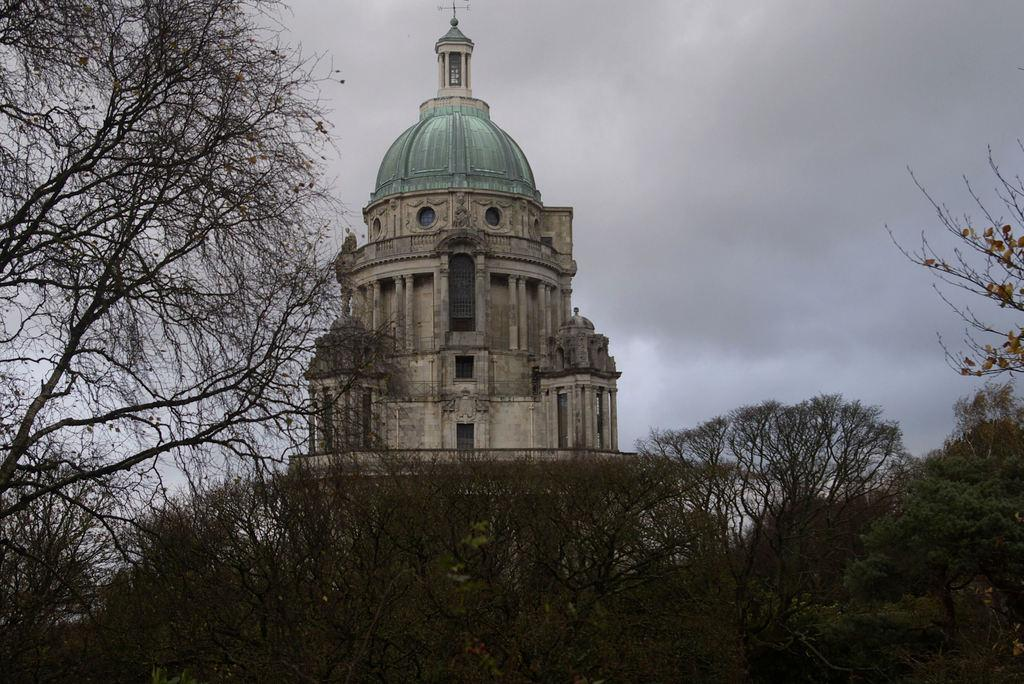What type of structure is present in the image? There is a building in the image. What other natural elements can be seen in the image? There are trees in the image. What is visible at the top of the image? The sky is visible at the top of the image. What can be observed in the sky? There are clouds in the sky. What feature is present on top of the building? There is a direction pole on the top of the building. What type of disease is affecting the trees in the image? There is no indication of any disease affecting the trees in the image; they appear healthy. 